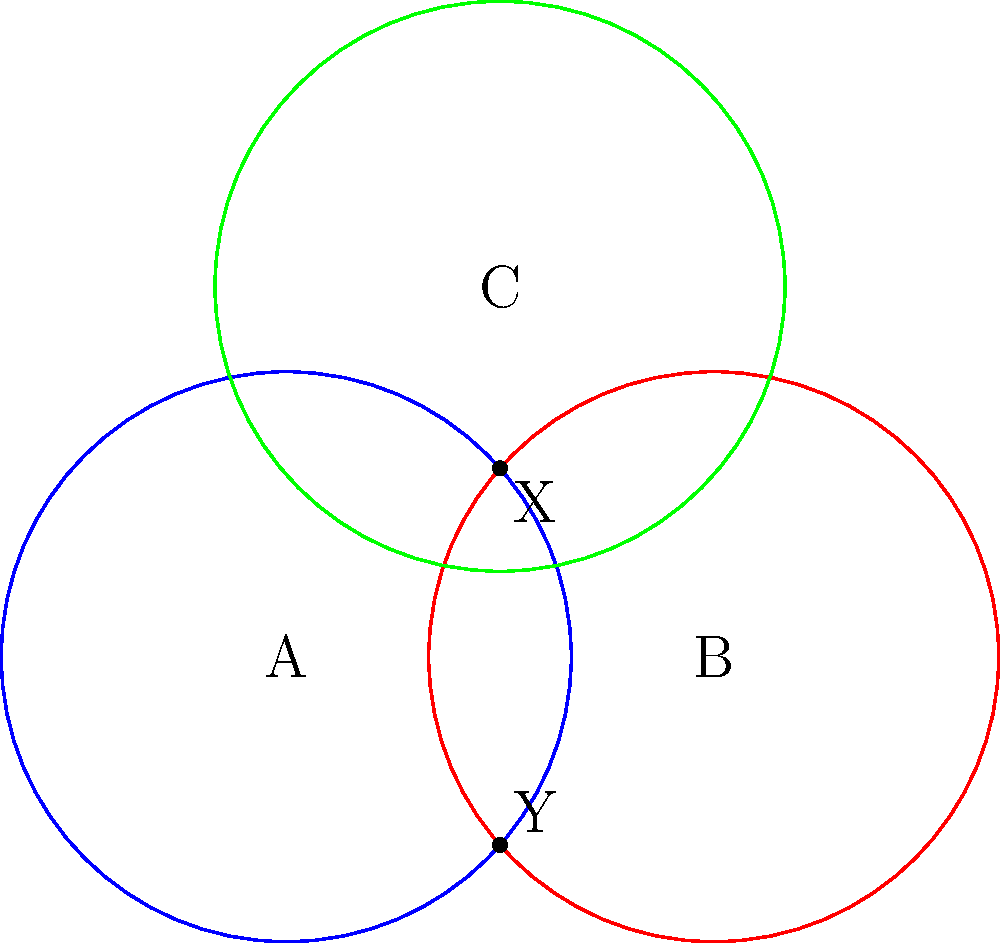In the diagram, three hazardous material containment zones (A, B, and C) are represented by circles. The zones intersect at points X and Y. If a safety barrier needs to be constructed along the boundaries of these zones, what is the minimum number of distinct regions that need to be considered for different safety protocols? To determine the number of distinct regions, we need to analyze the intersections of the containment zones:

1. First, identify the basic regions:
   - Region inside A only
   - Region inside B only
   - Region inside C only
   - Region outside all zones

2. Now, consider the intersections:
   - Region where A and B intersect (not including C)
   - Region where B and C intersect (not including A)
   - Region where A and C intersect (not including B)
   - Region where all three zones intersect (A, B, and C)

3. Count the regions:
   - 3 individual zones
   - 1 region outside all zones
   - 3 two-zone intersection regions
   - 1 three-zone intersection region

4. Sum up the total number of regions:
   $$3 + 1 + 3 + 1 = 8$$

Therefore, there are 8 distinct regions that need to be considered for different safety protocols when constructing the safety barrier.
Answer: 8 regions 